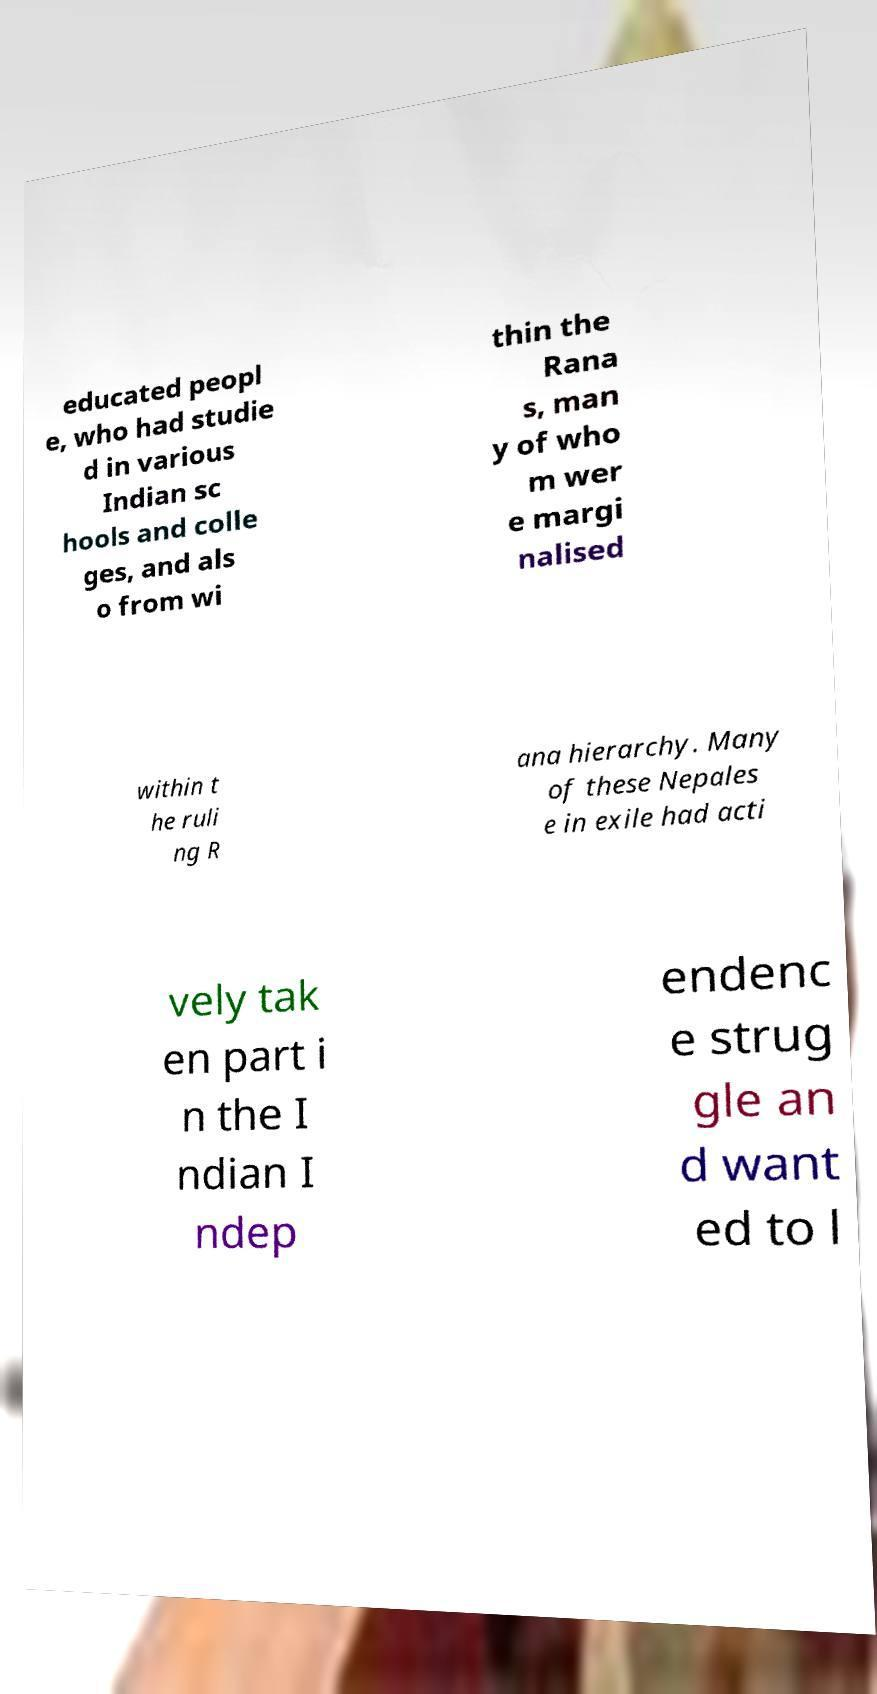There's text embedded in this image that I need extracted. Can you transcribe it verbatim? educated peopl e, who had studie d in various Indian sc hools and colle ges, and als o from wi thin the Rana s, man y of who m wer e margi nalised within t he ruli ng R ana hierarchy. Many of these Nepales e in exile had acti vely tak en part i n the I ndian I ndep endenc e strug gle an d want ed to l 